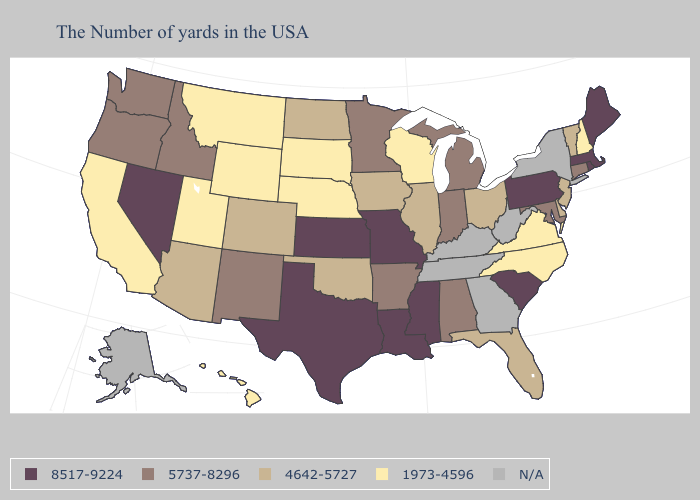Does the first symbol in the legend represent the smallest category?
Give a very brief answer. No. Among the states that border Mississippi , which have the lowest value?
Be succinct. Alabama, Arkansas. Among the states that border Iowa , does Illinois have the highest value?
Be succinct. No. What is the highest value in the USA?
Write a very short answer. 8517-9224. What is the highest value in the USA?
Keep it brief. 8517-9224. Among the states that border Montana , does North Dakota have the highest value?
Be succinct. No. Name the states that have a value in the range 4642-5727?
Write a very short answer. Vermont, New Jersey, Delaware, Ohio, Florida, Illinois, Iowa, Oklahoma, North Dakota, Colorado, Arizona. Name the states that have a value in the range 4642-5727?
Write a very short answer. Vermont, New Jersey, Delaware, Ohio, Florida, Illinois, Iowa, Oklahoma, North Dakota, Colorado, Arizona. Name the states that have a value in the range 8517-9224?
Write a very short answer. Maine, Massachusetts, Rhode Island, Pennsylvania, South Carolina, Mississippi, Louisiana, Missouri, Kansas, Texas, Nevada. Which states have the highest value in the USA?
Quick response, please. Maine, Massachusetts, Rhode Island, Pennsylvania, South Carolina, Mississippi, Louisiana, Missouri, Kansas, Texas, Nevada. Name the states that have a value in the range N/A?
Write a very short answer. New York, West Virginia, Georgia, Kentucky, Tennessee, Alaska. Name the states that have a value in the range 5737-8296?
Concise answer only. Connecticut, Maryland, Michigan, Indiana, Alabama, Arkansas, Minnesota, New Mexico, Idaho, Washington, Oregon. Name the states that have a value in the range 4642-5727?
Give a very brief answer. Vermont, New Jersey, Delaware, Ohio, Florida, Illinois, Iowa, Oklahoma, North Dakota, Colorado, Arizona. 